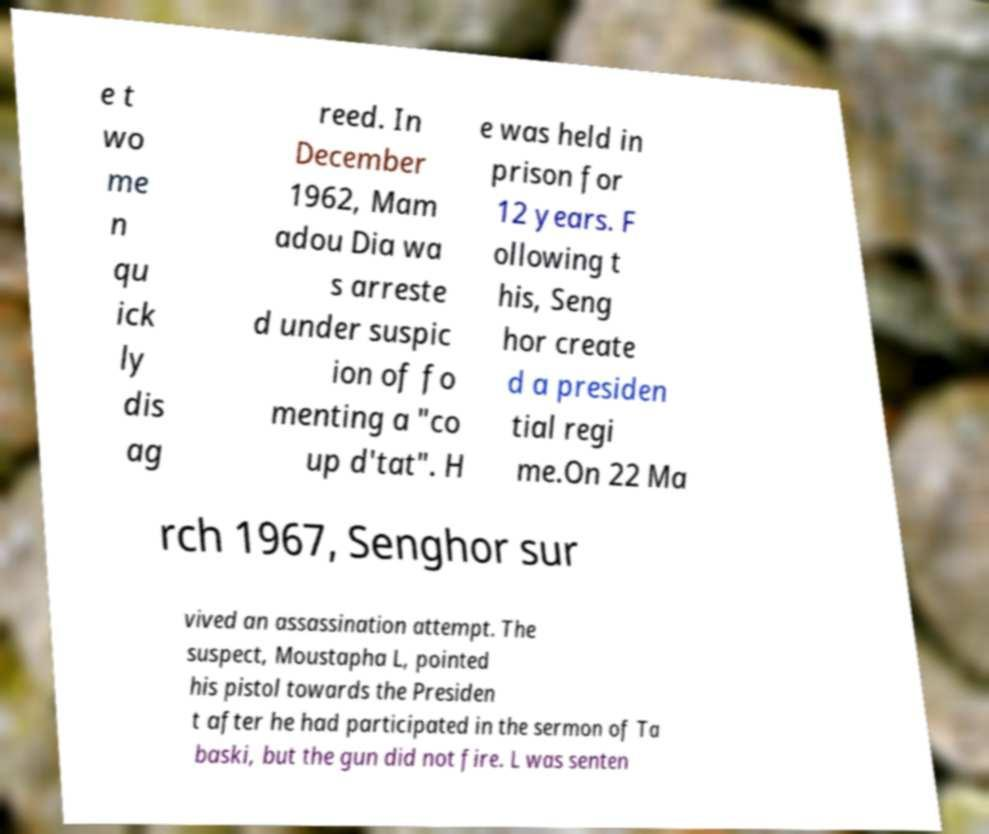Could you extract and type out the text from this image? e t wo me n qu ick ly dis ag reed. In December 1962, Mam adou Dia wa s arreste d under suspic ion of fo menting a "co up d'tat". H e was held in prison for 12 years. F ollowing t his, Seng hor create d a presiden tial regi me.On 22 Ma rch 1967, Senghor sur vived an assassination attempt. The suspect, Moustapha L, pointed his pistol towards the Presiden t after he had participated in the sermon of Ta baski, but the gun did not fire. L was senten 